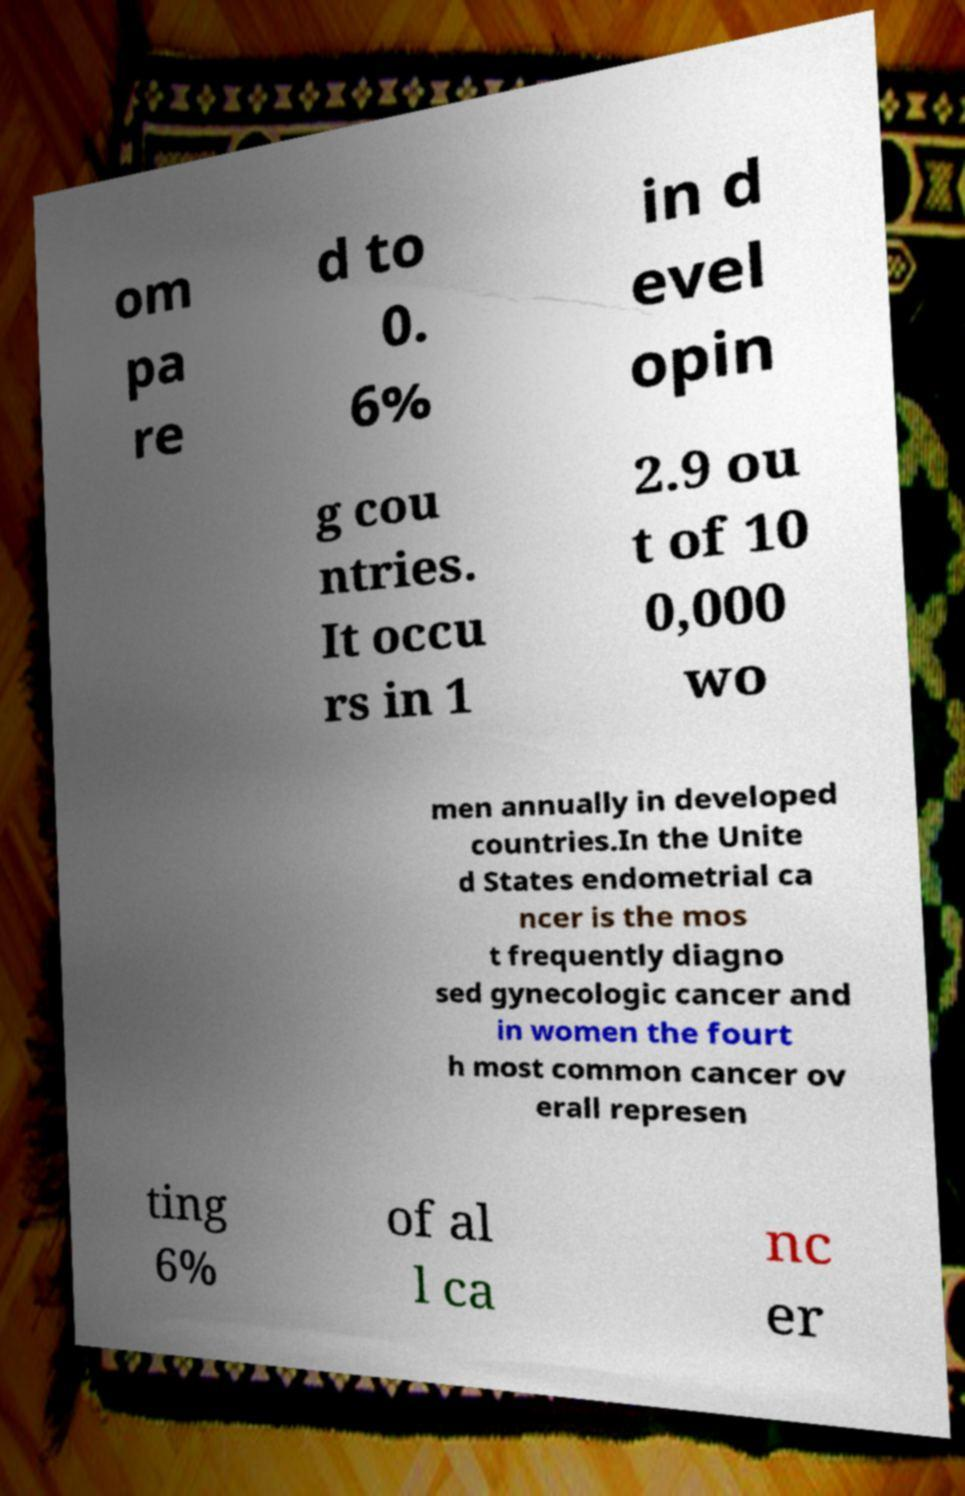Can you read and provide the text displayed in the image?This photo seems to have some interesting text. Can you extract and type it out for me? om pa re d to 0. 6% in d evel opin g cou ntries. It occu rs in 1 2.9 ou t of 10 0,000 wo men annually in developed countries.In the Unite d States endometrial ca ncer is the mos t frequently diagno sed gynecologic cancer and in women the fourt h most common cancer ov erall represen ting 6% of al l ca nc er 